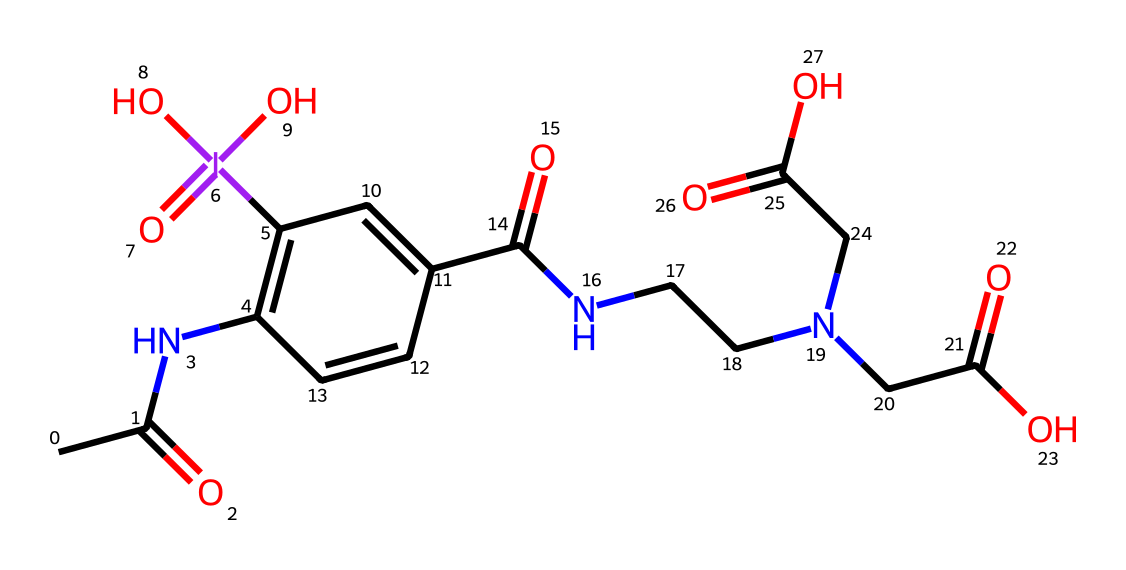What is the central atom in this compound? The structure displays iodine surrounded by multiple bonds and functional groups, indicating iodine is the central atom in this hypervalent compound.
Answer: iodine How many different types of atoms are present in this structure? Analyzing the SMILES representation reveals the presence of carbon, nitrogen, oxygen, and iodine, which totals to four distinct types of atoms.
Answer: four What functional groups are present in this compound? Observing the structure, we identify carboxylic acid groups and an amide group present, indicating the presence of multiple functional groups within the compound.
Answer: carboxylic acid and amide How many carbon atoms are in the compound? Counting the carbon atoms from the SMILES notation, there are a total of ten carbon atoms present, which gives us the total for this compound.
Answer: ten What is the oxidation state of iodine in this compound? By evaluating the bonds and the overall charge of the molecule, one can deduce that iodine typically exhibits a +5 oxidation state in hypervalent compounds like this one.
Answer: +5 Which part of the structure indicates its hypervalent nature? The presence of iodine forming more than four bonds, as seen here, illustrates the hypervalent character, distinguishing it from typical valencies of atoms.
Answer: iodine atoms with multiple bonds 